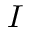Convert formula to latex. <formula><loc_0><loc_0><loc_500><loc_500>I</formula> 